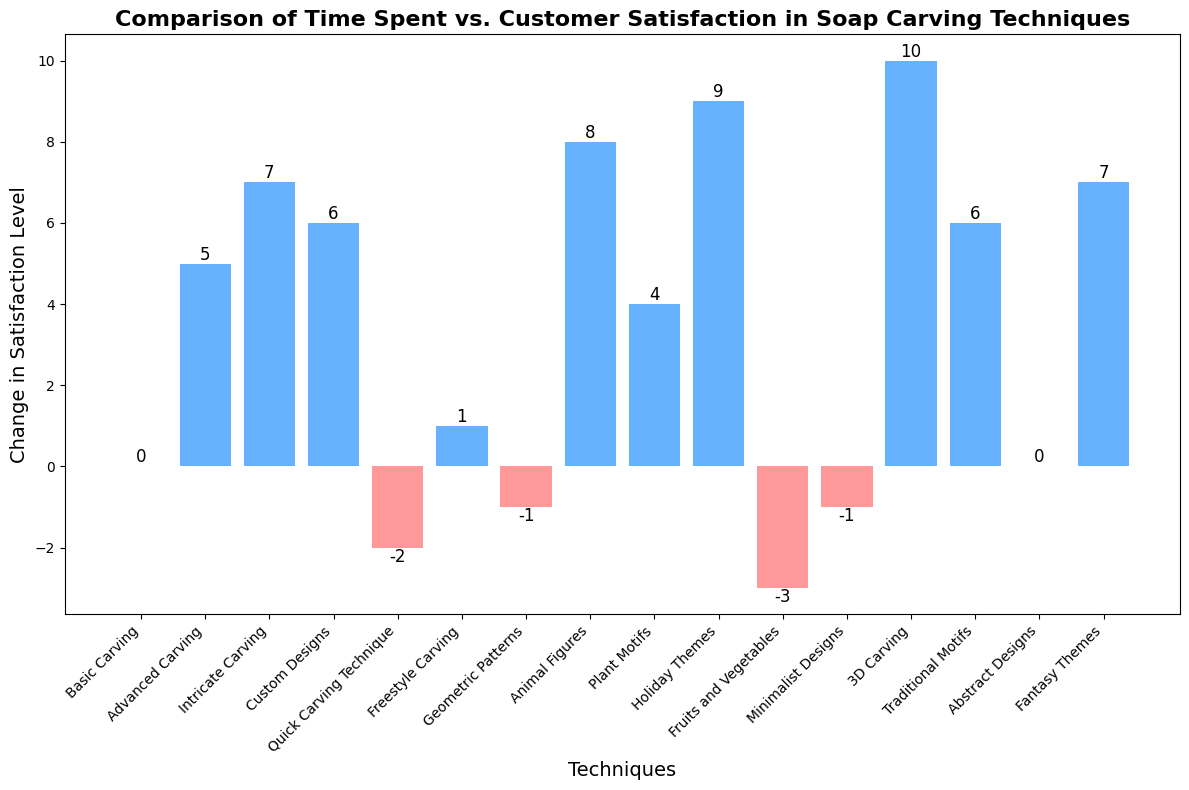Which technique resulted in the highest customer satisfaction change? The "3D Carving" technique has the highest bar which translates into the highest satisfaction change level.
Answer: 3D Carving Which techniques resulted in negative satisfaction changes? The techniques with red colored bars indicate negative satisfaction changes. The techniques are "Quick Carving Technique", "Geometric Patterns", "Fruits and Vegetables", and "Minimalist Designs".
Answer: Quick Carving Technique, Geometric Patterns, Fruits and Vegetables, Minimalist Designs How does the satisfaction change of "Holiday Themes" compare to "Basic Carving"? The satisfaction change of "Holiday Themes" is significantly higher compared to "Basic Carving". "Holiday Themes" has a change of +9 while "Basic Carving" has 0.
Answer: Holiday Themes has higher satisfaction change than Basic Carving What is the average change in satisfaction level for techniques investing 3 hours? The techniques investing 3 hours are "Advanced Carving", "Freestyle Carving", "Plant Motifs", "Fruits and Vegetables", and "Abstract Designs". Their changes in satisfaction levels are 5, 1, 4, -3, and 0 respectively. The average is (5 + 1 + 4 - 3 + 0) / 5 = 1.4
Answer: 1.4 Which two techniques, each with 4 hours invested, have the highest and lowest satisfaction changes? The techniques with 4 hours invested are "Custom Designs", "Geometric Patterns", and "Traditional Motifs". Among these, "Traditional Motifs" and "Custom Designs" have the highest satisfaction change at +6, and "Geometric Patterns" has the lowest satisfaction change at -1.
Answer: Traditional Motifs and Custom Designs have the highest, Geometric Patterns has the lowest What is the total change in satisfaction for techniques involving 5 or more hours? Techniques that involve 5 or more hours are "Intricate Carving" (+7), "Animal Figures" (+8), "Holiday Themes" (+9), "3D Carving" (+10), and "Fantasy Themes" (+7). Summing them: 7 + 8 + 9 + 10 + 7 = 41.
Answer: 41 What is the satisfaction change difference between "Intricate Carving" and "Quick Carving Technique"? The satisfaction change for "Intricate Carving" is +7 and for "Quick Carving Technique" is -2. The difference is 7 - (-2) = 9.
Answer: 9 Which technique has a zero change in satisfaction level? The techniques with a zero satisfaction change level are "Basic Carving" and "Abstract Designs".
Answer: Basic Carving and Abstract Designs 